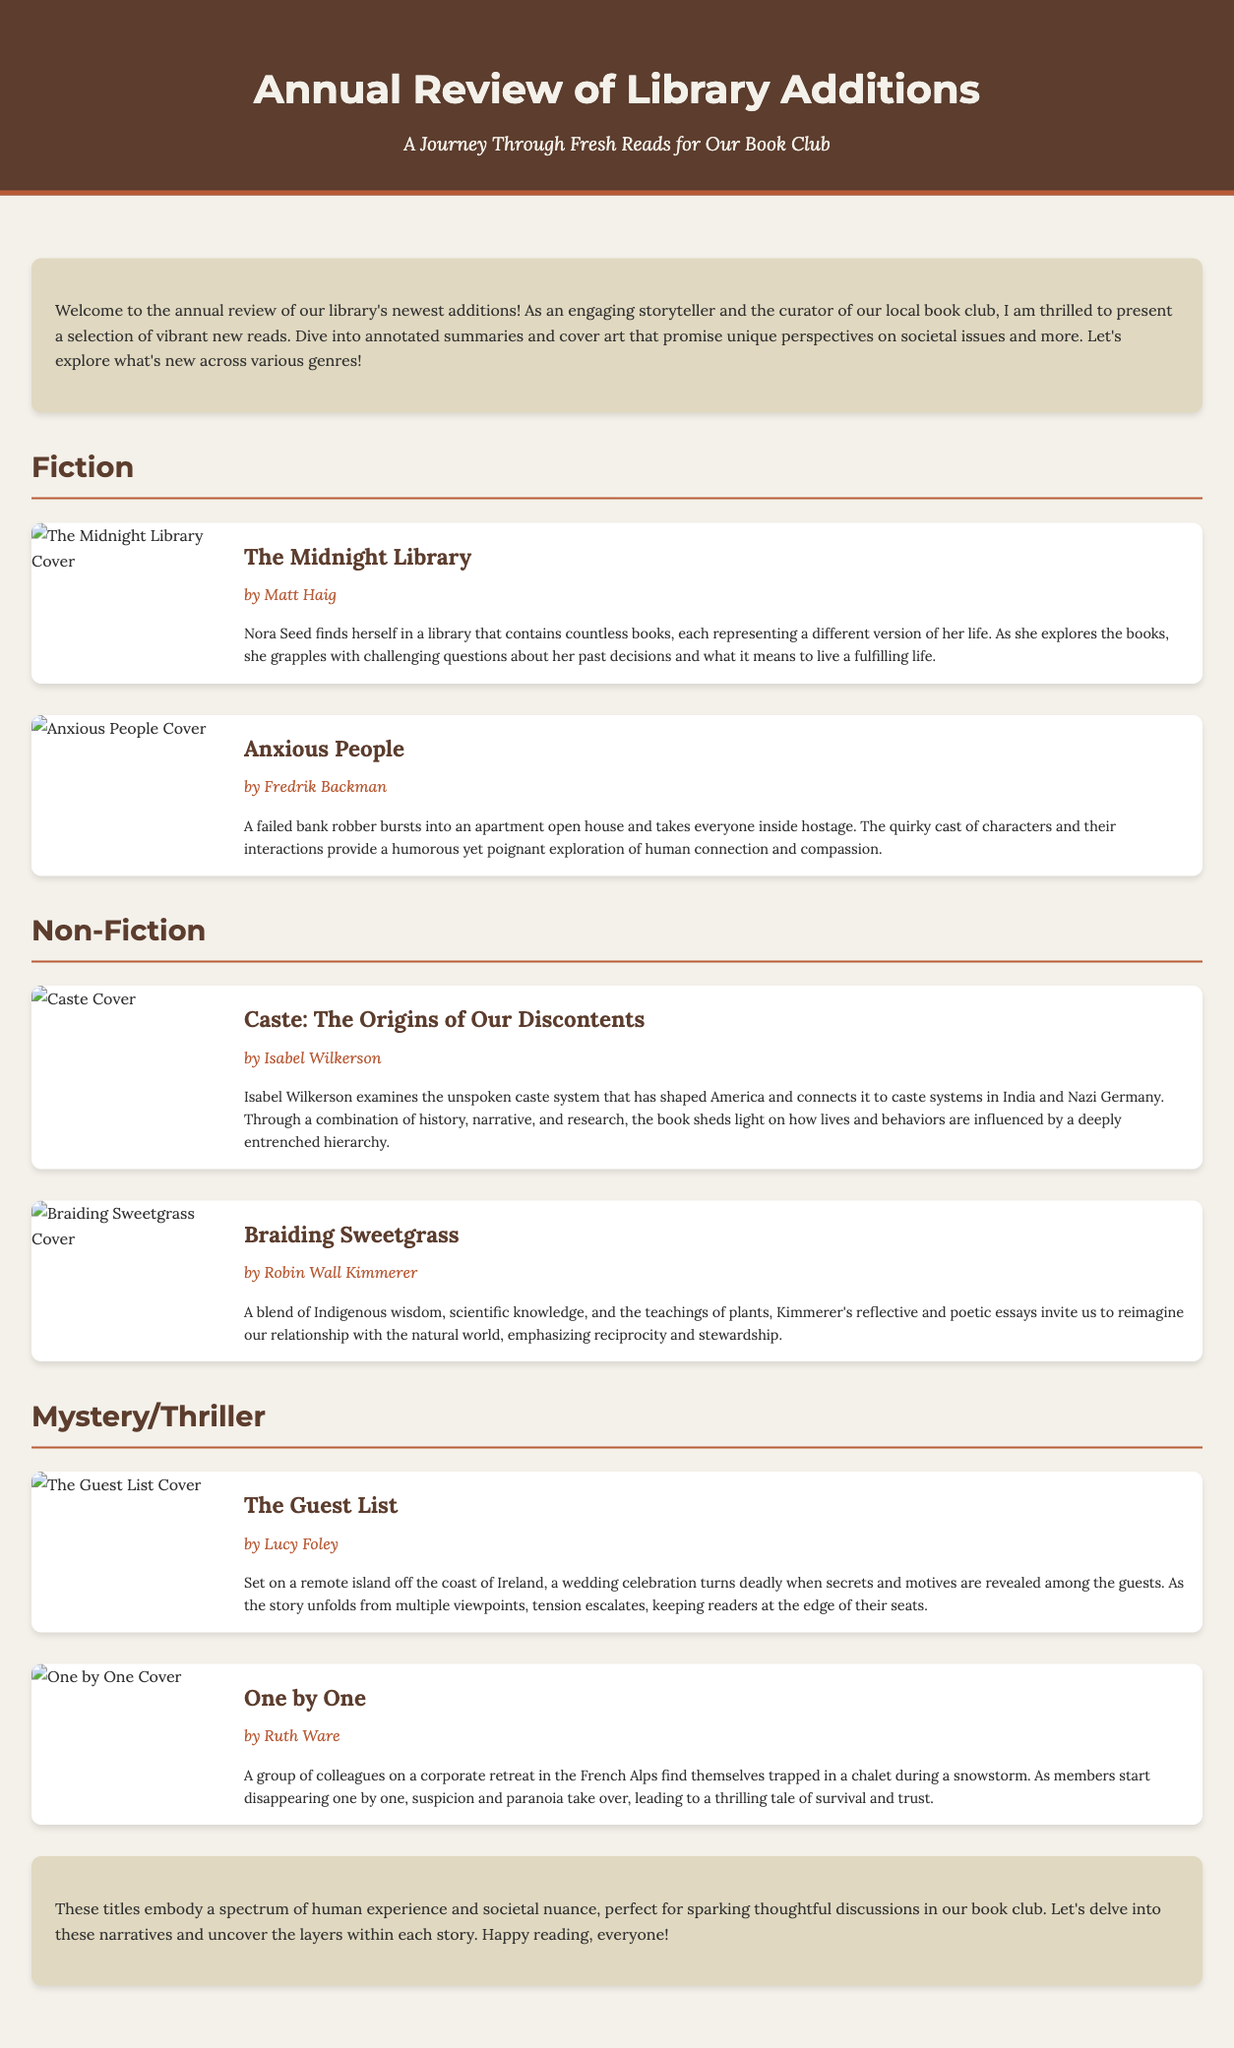What is the title of the first fiction book listed? The title of the first fiction book is stated clearly at the beginning of the fiction section.
Answer: The Midnight Library Who is the author of "Braiding Sweetgrass"? The author of this non-fiction book is specified under its title, providing direct authorship information.
Answer: Robin Wall Kimmerer How many genres are covered in the document? The document includes distinct sections for different genres of books, which can be counted.
Answer: Three What is the main theme explored in "Caste: The Origins of Our Discontents"? The main theme is discussed in the summary of the non-fiction book, highlighting its focus area.
Answer: Caste system Which book features a humorous exploration of human connection? The summary of the book includes a description of humor intertwined with themes of connection.
Answer: Anxious People What type of event is central to "The Guest List"? The central event of this mystery/thriller book is highlighted in the title and summary as a specific gathering.
Answer: Wedding How many books are listed under the Mystery/Thriller section? By counting the number of distinct book entries under the corresponding genre section, this information can be found.
Answer: Two What visual element accompanies each book summary? Each book summary is paired with a visual component that adds to the overall appeal of the document.
Answer: Cover art 